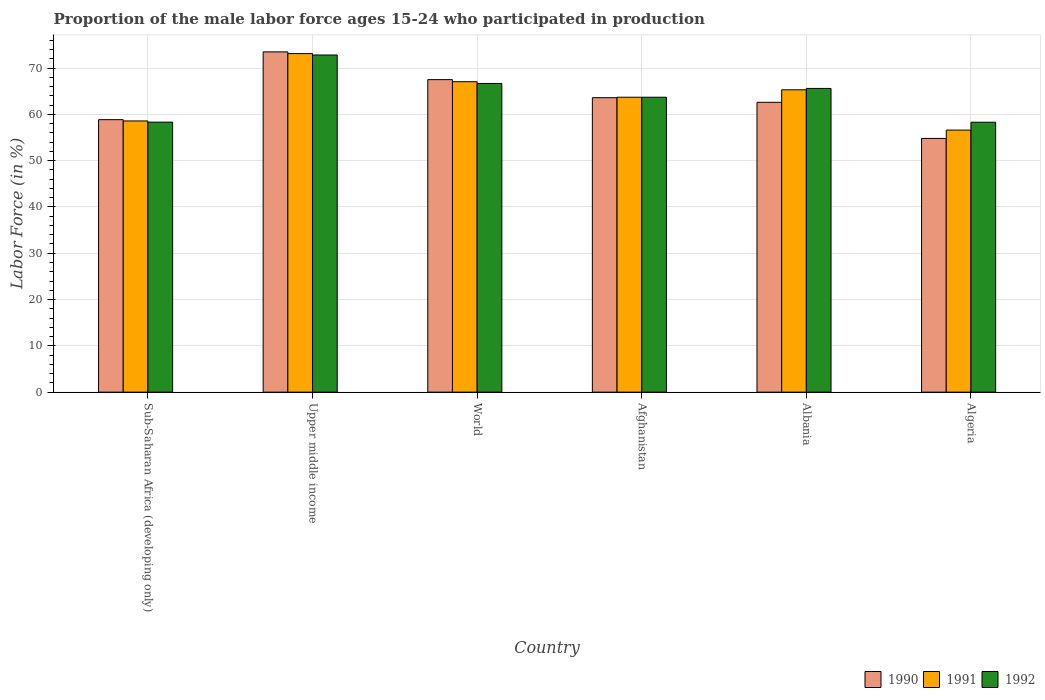How many different coloured bars are there?
Provide a succinct answer. 3. How many groups of bars are there?
Offer a very short reply. 6. Are the number of bars per tick equal to the number of legend labels?
Your answer should be very brief. Yes. Are the number of bars on each tick of the X-axis equal?
Provide a succinct answer. Yes. What is the label of the 5th group of bars from the left?
Give a very brief answer. Albania. In how many cases, is the number of bars for a given country not equal to the number of legend labels?
Offer a terse response. 0. What is the proportion of the male labor force who participated in production in 1992 in Albania?
Provide a short and direct response. 65.6. Across all countries, what is the maximum proportion of the male labor force who participated in production in 1992?
Provide a succinct answer. 72.82. Across all countries, what is the minimum proportion of the male labor force who participated in production in 1990?
Your response must be concise. 54.8. In which country was the proportion of the male labor force who participated in production in 1990 maximum?
Your answer should be very brief. Upper middle income. In which country was the proportion of the male labor force who participated in production in 1992 minimum?
Provide a succinct answer. Algeria. What is the total proportion of the male labor force who participated in production in 1991 in the graph?
Ensure brevity in your answer.  384.35. What is the difference between the proportion of the male labor force who participated in production in 1991 in Albania and that in Upper middle income?
Offer a very short reply. -7.83. What is the difference between the proportion of the male labor force who participated in production in 1992 in Upper middle income and the proportion of the male labor force who participated in production in 1990 in Algeria?
Provide a short and direct response. 18.02. What is the average proportion of the male labor force who participated in production in 1990 per country?
Offer a terse response. 63.47. What is the difference between the proportion of the male labor force who participated in production of/in 1990 and proportion of the male labor force who participated in production of/in 1992 in Albania?
Your answer should be compact. -3. In how many countries, is the proportion of the male labor force who participated in production in 1990 greater than 48 %?
Your answer should be compact. 6. What is the ratio of the proportion of the male labor force who participated in production in 1992 in Algeria to that in World?
Provide a short and direct response. 0.87. Is the proportion of the male labor force who participated in production in 1991 in Afghanistan less than that in Albania?
Offer a terse response. Yes. What is the difference between the highest and the second highest proportion of the male labor force who participated in production in 1991?
Offer a very short reply. -7.83. What is the difference between the highest and the lowest proportion of the male labor force who participated in production in 1990?
Your answer should be compact. 18.69. Is the sum of the proportion of the male labor force who participated in production in 1990 in Afghanistan and Sub-Saharan Africa (developing only) greater than the maximum proportion of the male labor force who participated in production in 1991 across all countries?
Your answer should be compact. Yes. What does the 1st bar from the left in Afghanistan represents?
Give a very brief answer. 1990. How many bars are there?
Make the answer very short. 18. How many countries are there in the graph?
Provide a succinct answer. 6. What is the difference between two consecutive major ticks on the Y-axis?
Provide a succinct answer. 10. Where does the legend appear in the graph?
Offer a terse response. Bottom right. How many legend labels are there?
Ensure brevity in your answer.  3. How are the legend labels stacked?
Make the answer very short. Horizontal. What is the title of the graph?
Your response must be concise. Proportion of the male labor force ages 15-24 who participated in production. Does "1996" appear as one of the legend labels in the graph?
Provide a succinct answer. No. What is the label or title of the Y-axis?
Your response must be concise. Labor Force (in %). What is the Labor Force (in %) in 1990 in Sub-Saharan Africa (developing only)?
Provide a succinct answer. 58.85. What is the Labor Force (in %) of 1991 in Sub-Saharan Africa (developing only)?
Provide a succinct answer. 58.57. What is the Labor Force (in %) in 1992 in Sub-Saharan Africa (developing only)?
Give a very brief answer. 58.32. What is the Labor Force (in %) in 1990 in Upper middle income?
Provide a succinct answer. 73.49. What is the Labor Force (in %) of 1991 in Upper middle income?
Your response must be concise. 73.13. What is the Labor Force (in %) in 1992 in Upper middle income?
Give a very brief answer. 72.82. What is the Labor Force (in %) in 1990 in World?
Your response must be concise. 67.5. What is the Labor Force (in %) in 1991 in World?
Give a very brief answer. 67.05. What is the Labor Force (in %) of 1992 in World?
Make the answer very short. 66.67. What is the Labor Force (in %) in 1990 in Afghanistan?
Ensure brevity in your answer.  63.6. What is the Labor Force (in %) of 1991 in Afghanistan?
Provide a succinct answer. 63.7. What is the Labor Force (in %) of 1992 in Afghanistan?
Your answer should be compact. 63.7. What is the Labor Force (in %) of 1990 in Albania?
Offer a terse response. 62.6. What is the Labor Force (in %) in 1991 in Albania?
Offer a very short reply. 65.3. What is the Labor Force (in %) in 1992 in Albania?
Offer a very short reply. 65.6. What is the Labor Force (in %) in 1990 in Algeria?
Make the answer very short. 54.8. What is the Labor Force (in %) of 1991 in Algeria?
Offer a very short reply. 56.6. What is the Labor Force (in %) in 1992 in Algeria?
Provide a succinct answer. 58.3. Across all countries, what is the maximum Labor Force (in %) in 1990?
Your answer should be very brief. 73.49. Across all countries, what is the maximum Labor Force (in %) in 1991?
Your response must be concise. 73.13. Across all countries, what is the maximum Labor Force (in %) of 1992?
Make the answer very short. 72.82. Across all countries, what is the minimum Labor Force (in %) in 1990?
Your answer should be very brief. 54.8. Across all countries, what is the minimum Labor Force (in %) of 1991?
Provide a succinct answer. 56.6. Across all countries, what is the minimum Labor Force (in %) of 1992?
Your answer should be compact. 58.3. What is the total Labor Force (in %) of 1990 in the graph?
Your answer should be compact. 380.84. What is the total Labor Force (in %) of 1991 in the graph?
Keep it short and to the point. 384.35. What is the total Labor Force (in %) of 1992 in the graph?
Keep it short and to the point. 385.41. What is the difference between the Labor Force (in %) of 1990 in Sub-Saharan Africa (developing only) and that in Upper middle income?
Provide a short and direct response. -14.64. What is the difference between the Labor Force (in %) in 1991 in Sub-Saharan Africa (developing only) and that in Upper middle income?
Offer a terse response. -14.55. What is the difference between the Labor Force (in %) in 1992 in Sub-Saharan Africa (developing only) and that in Upper middle income?
Your answer should be very brief. -14.5. What is the difference between the Labor Force (in %) in 1990 in Sub-Saharan Africa (developing only) and that in World?
Provide a succinct answer. -8.65. What is the difference between the Labor Force (in %) in 1991 in Sub-Saharan Africa (developing only) and that in World?
Ensure brevity in your answer.  -8.48. What is the difference between the Labor Force (in %) in 1992 in Sub-Saharan Africa (developing only) and that in World?
Give a very brief answer. -8.35. What is the difference between the Labor Force (in %) in 1990 in Sub-Saharan Africa (developing only) and that in Afghanistan?
Offer a terse response. -4.75. What is the difference between the Labor Force (in %) in 1991 in Sub-Saharan Africa (developing only) and that in Afghanistan?
Provide a short and direct response. -5.13. What is the difference between the Labor Force (in %) in 1992 in Sub-Saharan Africa (developing only) and that in Afghanistan?
Ensure brevity in your answer.  -5.38. What is the difference between the Labor Force (in %) in 1990 in Sub-Saharan Africa (developing only) and that in Albania?
Provide a succinct answer. -3.75. What is the difference between the Labor Force (in %) of 1991 in Sub-Saharan Africa (developing only) and that in Albania?
Your answer should be compact. -6.73. What is the difference between the Labor Force (in %) in 1992 in Sub-Saharan Africa (developing only) and that in Albania?
Keep it short and to the point. -7.28. What is the difference between the Labor Force (in %) in 1990 in Sub-Saharan Africa (developing only) and that in Algeria?
Offer a very short reply. 4.05. What is the difference between the Labor Force (in %) in 1991 in Sub-Saharan Africa (developing only) and that in Algeria?
Ensure brevity in your answer.  1.97. What is the difference between the Labor Force (in %) in 1992 in Sub-Saharan Africa (developing only) and that in Algeria?
Make the answer very short. 0.02. What is the difference between the Labor Force (in %) of 1990 in Upper middle income and that in World?
Your response must be concise. 5.99. What is the difference between the Labor Force (in %) of 1991 in Upper middle income and that in World?
Offer a terse response. 6.07. What is the difference between the Labor Force (in %) of 1992 in Upper middle income and that in World?
Make the answer very short. 6.15. What is the difference between the Labor Force (in %) of 1990 in Upper middle income and that in Afghanistan?
Ensure brevity in your answer.  9.89. What is the difference between the Labor Force (in %) of 1991 in Upper middle income and that in Afghanistan?
Your response must be concise. 9.43. What is the difference between the Labor Force (in %) in 1992 in Upper middle income and that in Afghanistan?
Your answer should be compact. 9.12. What is the difference between the Labor Force (in %) in 1990 in Upper middle income and that in Albania?
Make the answer very short. 10.89. What is the difference between the Labor Force (in %) in 1991 in Upper middle income and that in Albania?
Ensure brevity in your answer.  7.83. What is the difference between the Labor Force (in %) of 1992 in Upper middle income and that in Albania?
Your answer should be very brief. 7.22. What is the difference between the Labor Force (in %) in 1990 in Upper middle income and that in Algeria?
Make the answer very short. 18.69. What is the difference between the Labor Force (in %) of 1991 in Upper middle income and that in Algeria?
Provide a succinct answer. 16.53. What is the difference between the Labor Force (in %) of 1992 in Upper middle income and that in Algeria?
Your response must be concise. 14.52. What is the difference between the Labor Force (in %) in 1990 in World and that in Afghanistan?
Your response must be concise. 3.9. What is the difference between the Labor Force (in %) of 1991 in World and that in Afghanistan?
Offer a terse response. 3.35. What is the difference between the Labor Force (in %) in 1992 in World and that in Afghanistan?
Give a very brief answer. 2.97. What is the difference between the Labor Force (in %) of 1990 in World and that in Albania?
Offer a terse response. 4.9. What is the difference between the Labor Force (in %) of 1991 in World and that in Albania?
Keep it short and to the point. 1.75. What is the difference between the Labor Force (in %) of 1992 in World and that in Albania?
Offer a terse response. 1.07. What is the difference between the Labor Force (in %) of 1990 in World and that in Algeria?
Make the answer very short. 12.7. What is the difference between the Labor Force (in %) in 1991 in World and that in Algeria?
Make the answer very short. 10.45. What is the difference between the Labor Force (in %) of 1992 in World and that in Algeria?
Offer a terse response. 8.37. What is the difference between the Labor Force (in %) in 1990 in Afghanistan and that in Albania?
Give a very brief answer. 1. What is the difference between the Labor Force (in %) in 1991 in Afghanistan and that in Albania?
Your answer should be very brief. -1.6. What is the difference between the Labor Force (in %) in 1990 in Afghanistan and that in Algeria?
Provide a succinct answer. 8.8. What is the difference between the Labor Force (in %) of 1990 in Albania and that in Algeria?
Offer a terse response. 7.8. What is the difference between the Labor Force (in %) of 1991 in Albania and that in Algeria?
Offer a very short reply. 8.7. What is the difference between the Labor Force (in %) in 1990 in Sub-Saharan Africa (developing only) and the Labor Force (in %) in 1991 in Upper middle income?
Ensure brevity in your answer.  -14.27. What is the difference between the Labor Force (in %) of 1990 in Sub-Saharan Africa (developing only) and the Labor Force (in %) of 1992 in Upper middle income?
Offer a very short reply. -13.97. What is the difference between the Labor Force (in %) of 1991 in Sub-Saharan Africa (developing only) and the Labor Force (in %) of 1992 in Upper middle income?
Provide a short and direct response. -14.24. What is the difference between the Labor Force (in %) in 1990 in Sub-Saharan Africa (developing only) and the Labor Force (in %) in 1991 in World?
Offer a very short reply. -8.2. What is the difference between the Labor Force (in %) of 1990 in Sub-Saharan Africa (developing only) and the Labor Force (in %) of 1992 in World?
Your response must be concise. -7.82. What is the difference between the Labor Force (in %) of 1991 in Sub-Saharan Africa (developing only) and the Labor Force (in %) of 1992 in World?
Give a very brief answer. -8.1. What is the difference between the Labor Force (in %) of 1990 in Sub-Saharan Africa (developing only) and the Labor Force (in %) of 1991 in Afghanistan?
Your response must be concise. -4.85. What is the difference between the Labor Force (in %) of 1990 in Sub-Saharan Africa (developing only) and the Labor Force (in %) of 1992 in Afghanistan?
Keep it short and to the point. -4.85. What is the difference between the Labor Force (in %) in 1991 in Sub-Saharan Africa (developing only) and the Labor Force (in %) in 1992 in Afghanistan?
Make the answer very short. -5.13. What is the difference between the Labor Force (in %) of 1990 in Sub-Saharan Africa (developing only) and the Labor Force (in %) of 1991 in Albania?
Offer a very short reply. -6.45. What is the difference between the Labor Force (in %) of 1990 in Sub-Saharan Africa (developing only) and the Labor Force (in %) of 1992 in Albania?
Ensure brevity in your answer.  -6.75. What is the difference between the Labor Force (in %) in 1991 in Sub-Saharan Africa (developing only) and the Labor Force (in %) in 1992 in Albania?
Keep it short and to the point. -7.03. What is the difference between the Labor Force (in %) of 1990 in Sub-Saharan Africa (developing only) and the Labor Force (in %) of 1991 in Algeria?
Offer a very short reply. 2.25. What is the difference between the Labor Force (in %) of 1990 in Sub-Saharan Africa (developing only) and the Labor Force (in %) of 1992 in Algeria?
Give a very brief answer. 0.55. What is the difference between the Labor Force (in %) of 1991 in Sub-Saharan Africa (developing only) and the Labor Force (in %) of 1992 in Algeria?
Make the answer very short. 0.27. What is the difference between the Labor Force (in %) of 1990 in Upper middle income and the Labor Force (in %) of 1991 in World?
Make the answer very short. 6.44. What is the difference between the Labor Force (in %) in 1990 in Upper middle income and the Labor Force (in %) in 1992 in World?
Provide a succinct answer. 6.82. What is the difference between the Labor Force (in %) of 1991 in Upper middle income and the Labor Force (in %) of 1992 in World?
Offer a terse response. 6.45. What is the difference between the Labor Force (in %) in 1990 in Upper middle income and the Labor Force (in %) in 1991 in Afghanistan?
Your answer should be compact. 9.79. What is the difference between the Labor Force (in %) of 1990 in Upper middle income and the Labor Force (in %) of 1992 in Afghanistan?
Offer a very short reply. 9.79. What is the difference between the Labor Force (in %) in 1991 in Upper middle income and the Labor Force (in %) in 1992 in Afghanistan?
Ensure brevity in your answer.  9.43. What is the difference between the Labor Force (in %) in 1990 in Upper middle income and the Labor Force (in %) in 1991 in Albania?
Your answer should be very brief. 8.19. What is the difference between the Labor Force (in %) in 1990 in Upper middle income and the Labor Force (in %) in 1992 in Albania?
Provide a succinct answer. 7.89. What is the difference between the Labor Force (in %) in 1991 in Upper middle income and the Labor Force (in %) in 1992 in Albania?
Your answer should be compact. 7.53. What is the difference between the Labor Force (in %) in 1990 in Upper middle income and the Labor Force (in %) in 1991 in Algeria?
Make the answer very short. 16.89. What is the difference between the Labor Force (in %) of 1990 in Upper middle income and the Labor Force (in %) of 1992 in Algeria?
Ensure brevity in your answer.  15.19. What is the difference between the Labor Force (in %) in 1991 in Upper middle income and the Labor Force (in %) in 1992 in Algeria?
Offer a terse response. 14.83. What is the difference between the Labor Force (in %) of 1990 in World and the Labor Force (in %) of 1991 in Afghanistan?
Your answer should be compact. 3.8. What is the difference between the Labor Force (in %) in 1990 in World and the Labor Force (in %) in 1992 in Afghanistan?
Give a very brief answer. 3.8. What is the difference between the Labor Force (in %) in 1991 in World and the Labor Force (in %) in 1992 in Afghanistan?
Offer a very short reply. 3.35. What is the difference between the Labor Force (in %) of 1990 in World and the Labor Force (in %) of 1991 in Albania?
Your answer should be compact. 2.2. What is the difference between the Labor Force (in %) in 1990 in World and the Labor Force (in %) in 1992 in Albania?
Offer a terse response. 1.9. What is the difference between the Labor Force (in %) of 1991 in World and the Labor Force (in %) of 1992 in Albania?
Your answer should be compact. 1.45. What is the difference between the Labor Force (in %) in 1990 in World and the Labor Force (in %) in 1991 in Algeria?
Your answer should be very brief. 10.9. What is the difference between the Labor Force (in %) of 1990 in World and the Labor Force (in %) of 1992 in Algeria?
Provide a succinct answer. 9.2. What is the difference between the Labor Force (in %) in 1991 in World and the Labor Force (in %) in 1992 in Algeria?
Your answer should be compact. 8.75. What is the difference between the Labor Force (in %) of 1990 in Afghanistan and the Labor Force (in %) of 1991 in Albania?
Provide a short and direct response. -1.7. What is the difference between the Labor Force (in %) in 1990 in Afghanistan and the Labor Force (in %) in 1991 in Algeria?
Your answer should be very brief. 7. What is the difference between the Labor Force (in %) of 1990 in Afghanistan and the Labor Force (in %) of 1992 in Algeria?
Offer a very short reply. 5.3. What is the difference between the Labor Force (in %) of 1991 in Afghanistan and the Labor Force (in %) of 1992 in Algeria?
Your answer should be very brief. 5.4. What is the difference between the Labor Force (in %) in 1990 in Albania and the Labor Force (in %) in 1991 in Algeria?
Your answer should be compact. 6. What is the difference between the Labor Force (in %) in 1990 in Albania and the Labor Force (in %) in 1992 in Algeria?
Provide a succinct answer. 4.3. What is the average Labor Force (in %) in 1990 per country?
Your response must be concise. 63.47. What is the average Labor Force (in %) in 1991 per country?
Offer a terse response. 64.06. What is the average Labor Force (in %) of 1992 per country?
Provide a short and direct response. 64.24. What is the difference between the Labor Force (in %) in 1990 and Labor Force (in %) in 1991 in Sub-Saharan Africa (developing only)?
Keep it short and to the point. 0.28. What is the difference between the Labor Force (in %) in 1990 and Labor Force (in %) in 1992 in Sub-Saharan Africa (developing only)?
Provide a short and direct response. 0.53. What is the difference between the Labor Force (in %) of 1991 and Labor Force (in %) of 1992 in Sub-Saharan Africa (developing only)?
Offer a very short reply. 0.25. What is the difference between the Labor Force (in %) of 1990 and Labor Force (in %) of 1991 in Upper middle income?
Give a very brief answer. 0.37. What is the difference between the Labor Force (in %) in 1990 and Labor Force (in %) in 1992 in Upper middle income?
Offer a very short reply. 0.67. What is the difference between the Labor Force (in %) in 1991 and Labor Force (in %) in 1992 in Upper middle income?
Give a very brief answer. 0.31. What is the difference between the Labor Force (in %) in 1990 and Labor Force (in %) in 1991 in World?
Provide a short and direct response. 0.45. What is the difference between the Labor Force (in %) in 1990 and Labor Force (in %) in 1992 in World?
Keep it short and to the point. 0.83. What is the difference between the Labor Force (in %) in 1991 and Labor Force (in %) in 1992 in World?
Provide a short and direct response. 0.38. What is the difference between the Labor Force (in %) in 1990 and Labor Force (in %) in 1992 in Afghanistan?
Provide a short and direct response. -0.1. What is the difference between the Labor Force (in %) in 1990 and Labor Force (in %) in 1991 in Albania?
Keep it short and to the point. -2.7. What is the difference between the Labor Force (in %) of 1991 and Labor Force (in %) of 1992 in Albania?
Your answer should be very brief. -0.3. What is the difference between the Labor Force (in %) in 1990 and Labor Force (in %) in 1991 in Algeria?
Your answer should be compact. -1.8. What is the difference between the Labor Force (in %) of 1990 and Labor Force (in %) of 1992 in Algeria?
Your answer should be very brief. -3.5. What is the ratio of the Labor Force (in %) in 1990 in Sub-Saharan Africa (developing only) to that in Upper middle income?
Offer a terse response. 0.8. What is the ratio of the Labor Force (in %) of 1991 in Sub-Saharan Africa (developing only) to that in Upper middle income?
Provide a short and direct response. 0.8. What is the ratio of the Labor Force (in %) in 1992 in Sub-Saharan Africa (developing only) to that in Upper middle income?
Your answer should be very brief. 0.8. What is the ratio of the Labor Force (in %) in 1990 in Sub-Saharan Africa (developing only) to that in World?
Offer a terse response. 0.87. What is the ratio of the Labor Force (in %) in 1991 in Sub-Saharan Africa (developing only) to that in World?
Provide a short and direct response. 0.87. What is the ratio of the Labor Force (in %) of 1992 in Sub-Saharan Africa (developing only) to that in World?
Keep it short and to the point. 0.87. What is the ratio of the Labor Force (in %) of 1990 in Sub-Saharan Africa (developing only) to that in Afghanistan?
Offer a terse response. 0.93. What is the ratio of the Labor Force (in %) of 1991 in Sub-Saharan Africa (developing only) to that in Afghanistan?
Ensure brevity in your answer.  0.92. What is the ratio of the Labor Force (in %) in 1992 in Sub-Saharan Africa (developing only) to that in Afghanistan?
Your answer should be compact. 0.92. What is the ratio of the Labor Force (in %) of 1990 in Sub-Saharan Africa (developing only) to that in Albania?
Make the answer very short. 0.94. What is the ratio of the Labor Force (in %) of 1991 in Sub-Saharan Africa (developing only) to that in Albania?
Make the answer very short. 0.9. What is the ratio of the Labor Force (in %) of 1992 in Sub-Saharan Africa (developing only) to that in Albania?
Make the answer very short. 0.89. What is the ratio of the Labor Force (in %) of 1990 in Sub-Saharan Africa (developing only) to that in Algeria?
Provide a succinct answer. 1.07. What is the ratio of the Labor Force (in %) in 1991 in Sub-Saharan Africa (developing only) to that in Algeria?
Make the answer very short. 1.03. What is the ratio of the Labor Force (in %) in 1992 in Sub-Saharan Africa (developing only) to that in Algeria?
Offer a very short reply. 1. What is the ratio of the Labor Force (in %) in 1990 in Upper middle income to that in World?
Offer a terse response. 1.09. What is the ratio of the Labor Force (in %) of 1991 in Upper middle income to that in World?
Your answer should be compact. 1.09. What is the ratio of the Labor Force (in %) in 1992 in Upper middle income to that in World?
Provide a succinct answer. 1.09. What is the ratio of the Labor Force (in %) of 1990 in Upper middle income to that in Afghanistan?
Ensure brevity in your answer.  1.16. What is the ratio of the Labor Force (in %) in 1991 in Upper middle income to that in Afghanistan?
Provide a succinct answer. 1.15. What is the ratio of the Labor Force (in %) in 1992 in Upper middle income to that in Afghanistan?
Ensure brevity in your answer.  1.14. What is the ratio of the Labor Force (in %) of 1990 in Upper middle income to that in Albania?
Your answer should be compact. 1.17. What is the ratio of the Labor Force (in %) of 1991 in Upper middle income to that in Albania?
Make the answer very short. 1.12. What is the ratio of the Labor Force (in %) in 1992 in Upper middle income to that in Albania?
Make the answer very short. 1.11. What is the ratio of the Labor Force (in %) in 1990 in Upper middle income to that in Algeria?
Provide a succinct answer. 1.34. What is the ratio of the Labor Force (in %) of 1991 in Upper middle income to that in Algeria?
Your answer should be very brief. 1.29. What is the ratio of the Labor Force (in %) of 1992 in Upper middle income to that in Algeria?
Give a very brief answer. 1.25. What is the ratio of the Labor Force (in %) in 1990 in World to that in Afghanistan?
Keep it short and to the point. 1.06. What is the ratio of the Labor Force (in %) in 1991 in World to that in Afghanistan?
Your answer should be very brief. 1.05. What is the ratio of the Labor Force (in %) in 1992 in World to that in Afghanistan?
Keep it short and to the point. 1.05. What is the ratio of the Labor Force (in %) in 1990 in World to that in Albania?
Make the answer very short. 1.08. What is the ratio of the Labor Force (in %) in 1991 in World to that in Albania?
Offer a very short reply. 1.03. What is the ratio of the Labor Force (in %) in 1992 in World to that in Albania?
Provide a short and direct response. 1.02. What is the ratio of the Labor Force (in %) in 1990 in World to that in Algeria?
Your response must be concise. 1.23. What is the ratio of the Labor Force (in %) in 1991 in World to that in Algeria?
Provide a short and direct response. 1.18. What is the ratio of the Labor Force (in %) of 1992 in World to that in Algeria?
Provide a succinct answer. 1.14. What is the ratio of the Labor Force (in %) of 1991 in Afghanistan to that in Albania?
Provide a succinct answer. 0.98. What is the ratio of the Labor Force (in %) of 1992 in Afghanistan to that in Albania?
Provide a short and direct response. 0.97. What is the ratio of the Labor Force (in %) of 1990 in Afghanistan to that in Algeria?
Make the answer very short. 1.16. What is the ratio of the Labor Force (in %) in 1991 in Afghanistan to that in Algeria?
Keep it short and to the point. 1.13. What is the ratio of the Labor Force (in %) of 1992 in Afghanistan to that in Algeria?
Ensure brevity in your answer.  1.09. What is the ratio of the Labor Force (in %) of 1990 in Albania to that in Algeria?
Your answer should be very brief. 1.14. What is the ratio of the Labor Force (in %) of 1991 in Albania to that in Algeria?
Your answer should be compact. 1.15. What is the ratio of the Labor Force (in %) of 1992 in Albania to that in Algeria?
Offer a very short reply. 1.13. What is the difference between the highest and the second highest Labor Force (in %) in 1990?
Give a very brief answer. 5.99. What is the difference between the highest and the second highest Labor Force (in %) of 1991?
Keep it short and to the point. 6.07. What is the difference between the highest and the second highest Labor Force (in %) in 1992?
Provide a short and direct response. 6.15. What is the difference between the highest and the lowest Labor Force (in %) of 1990?
Make the answer very short. 18.69. What is the difference between the highest and the lowest Labor Force (in %) of 1991?
Your response must be concise. 16.53. What is the difference between the highest and the lowest Labor Force (in %) of 1992?
Provide a short and direct response. 14.52. 